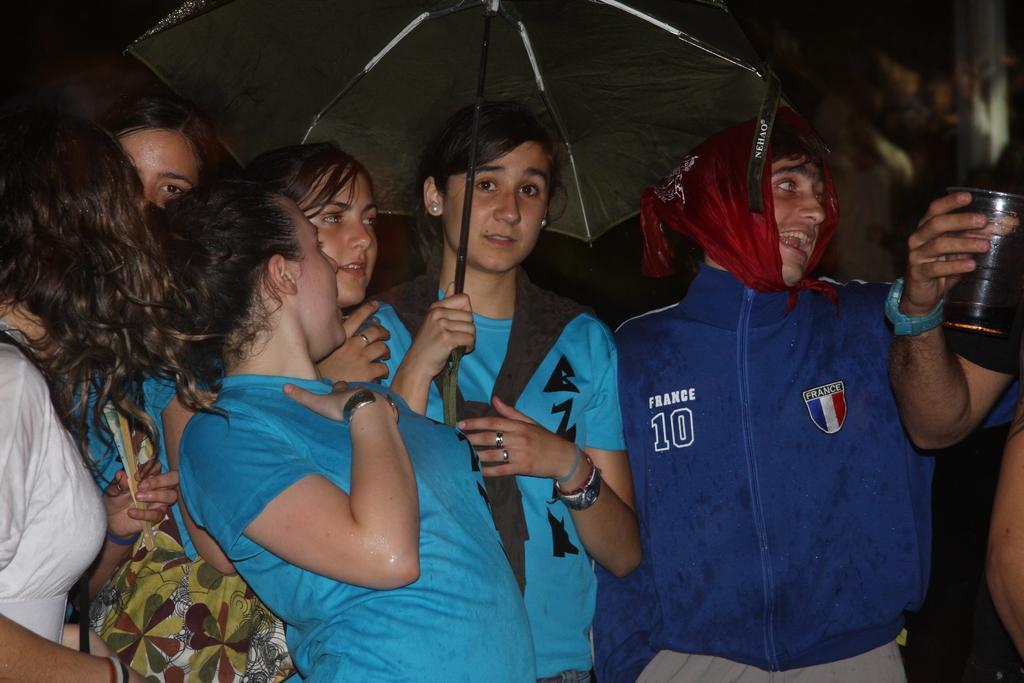Can you describe this image briefly? In this image we can see some people standing near the big wall, some people holding some objects and one woman holding one umbrella. 